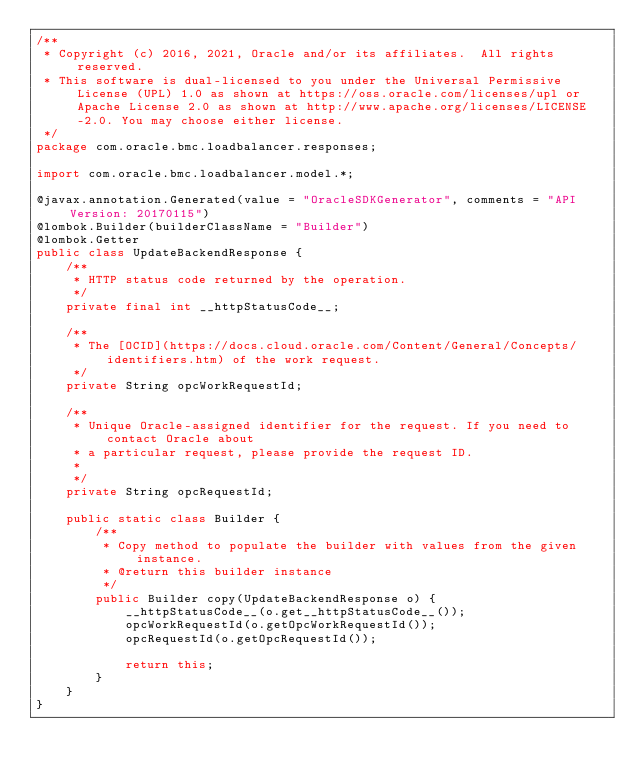<code> <loc_0><loc_0><loc_500><loc_500><_Java_>/**
 * Copyright (c) 2016, 2021, Oracle and/or its affiliates.  All rights reserved.
 * This software is dual-licensed to you under the Universal Permissive License (UPL) 1.0 as shown at https://oss.oracle.com/licenses/upl or Apache License 2.0 as shown at http://www.apache.org/licenses/LICENSE-2.0. You may choose either license.
 */
package com.oracle.bmc.loadbalancer.responses;

import com.oracle.bmc.loadbalancer.model.*;

@javax.annotation.Generated(value = "OracleSDKGenerator", comments = "API Version: 20170115")
@lombok.Builder(builderClassName = "Builder")
@lombok.Getter
public class UpdateBackendResponse {
    /**
     * HTTP status code returned by the operation.
     */
    private final int __httpStatusCode__;

    /**
     * The [OCID](https://docs.cloud.oracle.com/Content/General/Concepts/identifiers.htm) of the work request.
     */
    private String opcWorkRequestId;

    /**
     * Unique Oracle-assigned identifier for the request. If you need to contact Oracle about
     * a particular request, please provide the request ID.
     *
     */
    private String opcRequestId;

    public static class Builder {
        /**
         * Copy method to populate the builder with values from the given instance.
         * @return this builder instance
         */
        public Builder copy(UpdateBackendResponse o) {
            __httpStatusCode__(o.get__httpStatusCode__());
            opcWorkRequestId(o.getOpcWorkRequestId());
            opcRequestId(o.getOpcRequestId());

            return this;
        }
    }
}
</code> 